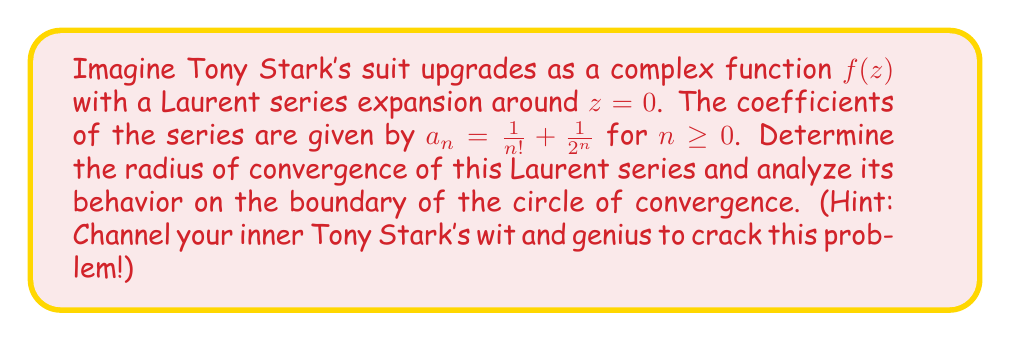Teach me how to tackle this problem. Let's approach this problem step-by-step, as if we were Tony Stark himself upgrading his suit:

1) The Laurent series expansion of $f(z)$ around $z=0$ is given by:

   $$f(z) = \sum_{n=0}^{\infty} a_n z^n = \sum_{n=0}^{\infty} (\frac{1}{n!} + \frac{1}{2^n}) z^n$$

2) To find the radius of convergence $R$, we use the formula:

   $$R = \frac{1}{\limsup_{n \to \infty} \sqrt[n]{|a_n|}}$$

3) We need to analyze $\limsup_{n \to \infty} \sqrt[n]{|a_n|}$:

   $$\limsup_{n \to \infty} \sqrt[n]{|\frac{1}{n!} + \frac{1}{2^n}|}$$

4) We can use the inequality $|\frac{1}{n!} + \frac{1}{2^n}| \leq |\frac{1}{n!}| + |\frac{1}{2^n}|$:

   $$\limsup_{n \to \infty} \sqrt[n]{|\frac{1}{n!} + \frac{1}{2^n}|} \leq \limsup_{n \to \infty} \sqrt[n]{(\frac{1}{n!} + \frac{1}{2^n})}$$

5) Now, we can split this into two parts:

   $$\limsup_{n \to \infty} \sqrt[n]{\frac{1}{n!}} + \limsup_{n \to \infty} \sqrt[n]{\frac{1}{2^n}}$$

6) For the first part, we use Stirling's approximation:
   
   $$\lim_{n \to \infty} \sqrt[n]{\frac{1}{n!}} = 0$$

7) For the second part:

   $$\lim_{n \to \infty} \sqrt[n]{\frac{1}{2^n}} = \frac{1}{2}$$

8) Therefore, $\limsup_{n \to \infty} \sqrt[n]{|a_n|} = \frac{1}{2}$

9) The radius of convergence is thus:

   $$R = \frac{1}{\frac{1}{2}} = 2$$

10) To analyze the behavior on the boundary $|z| = 2$, we need to check the series:

    $$\sum_{n=0}^{\infty} |\frac{1}{n!} + \frac{1}{2^n}| \cdot 2^n$$

11) This series diverges because $\lim_{n \to \infty} |\frac{1}{n!} + \frac{1}{2^n}| \cdot 2^n = 1 \neq 0$

Therefore, the series converges absolutely for $|z| < 2$ and diverges for $|z| > 2$. On the boundary $|z| = 2$, the series diverges.
Answer: The radius of convergence of the Laurent series is 2. The series converges absolutely for $|z| < 2$, diverges for $|z| > 2$, and diverges on the boundary $|z| = 2$. 